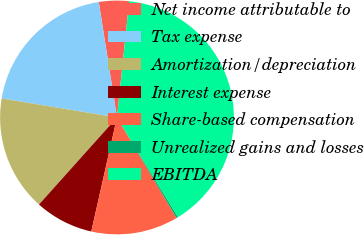Convert chart to OTSL. <chart><loc_0><loc_0><loc_500><loc_500><pie_chart><fcel>Net income attributable to<fcel>Tax expense<fcel>Amortization/depreciation<fcel>Interest expense<fcel>Share-based compensation<fcel>Unrealized gains and losses<fcel>EBITDA<nl><fcel>4.16%<fcel>19.91%<fcel>15.97%<fcel>8.1%<fcel>12.04%<fcel>0.23%<fcel>39.59%<nl></chart> 